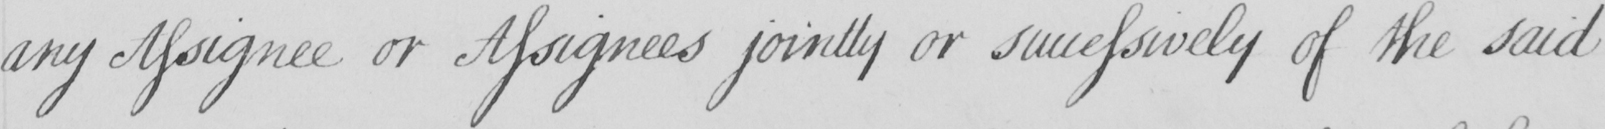Can you read and transcribe this handwriting? any Assignee or Assignees jointly or successively of the said 